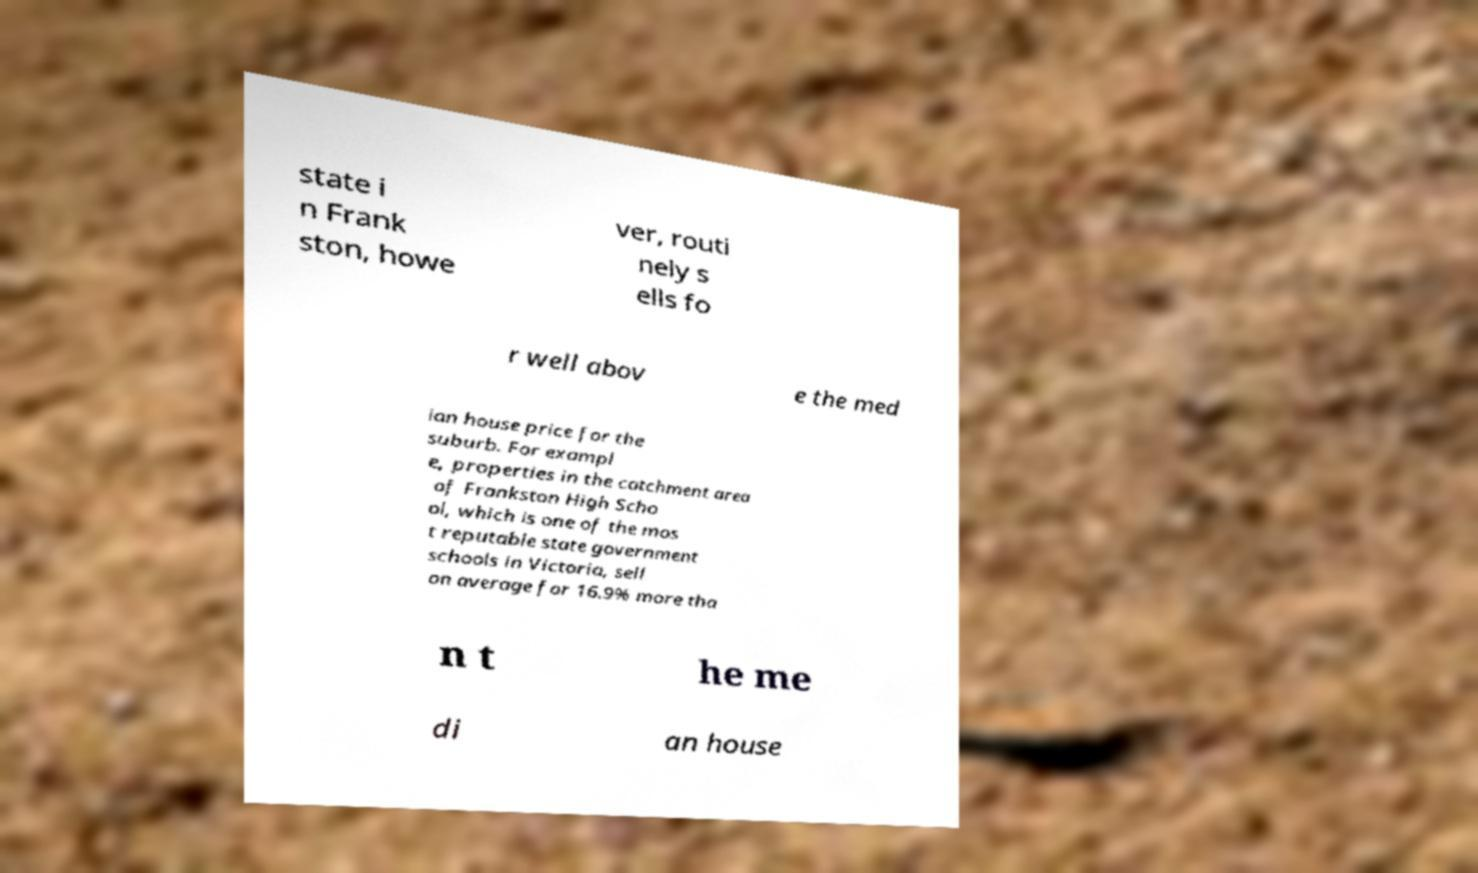What messages or text are displayed in this image? I need them in a readable, typed format. state i n Frank ston, howe ver, routi nely s ells fo r well abov e the med ian house price for the suburb. For exampl e, properties in the catchment area of Frankston High Scho ol, which is one of the mos t reputable state government schools in Victoria, sell on average for 16.9% more tha n t he me di an house 